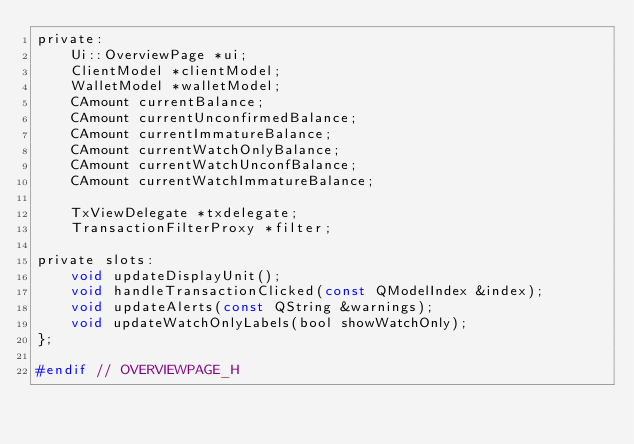Convert code to text. <code><loc_0><loc_0><loc_500><loc_500><_C_>private:
    Ui::OverviewPage *ui;
    ClientModel *clientModel;
    WalletModel *walletModel;
    CAmount currentBalance;
    CAmount currentUnconfirmedBalance;
    CAmount currentImmatureBalance;
    CAmount currentWatchOnlyBalance;
    CAmount currentWatchUnconfBalance;
    CAmount currentWatchImmatureBalance;

    TxViewDelegate *txdelegate;
    TransactionFilterProxy *filter;

private slots:
    void updateDisplayUnit();
    void handleTransactionClicked(const QModelIndex &index);
    void updateAlerts(const QString &warnings);
    void updateWatchOnlyLabels(bool showWatchOnly);
};

#endif // OVERVIEWPAGE_H
</code> 